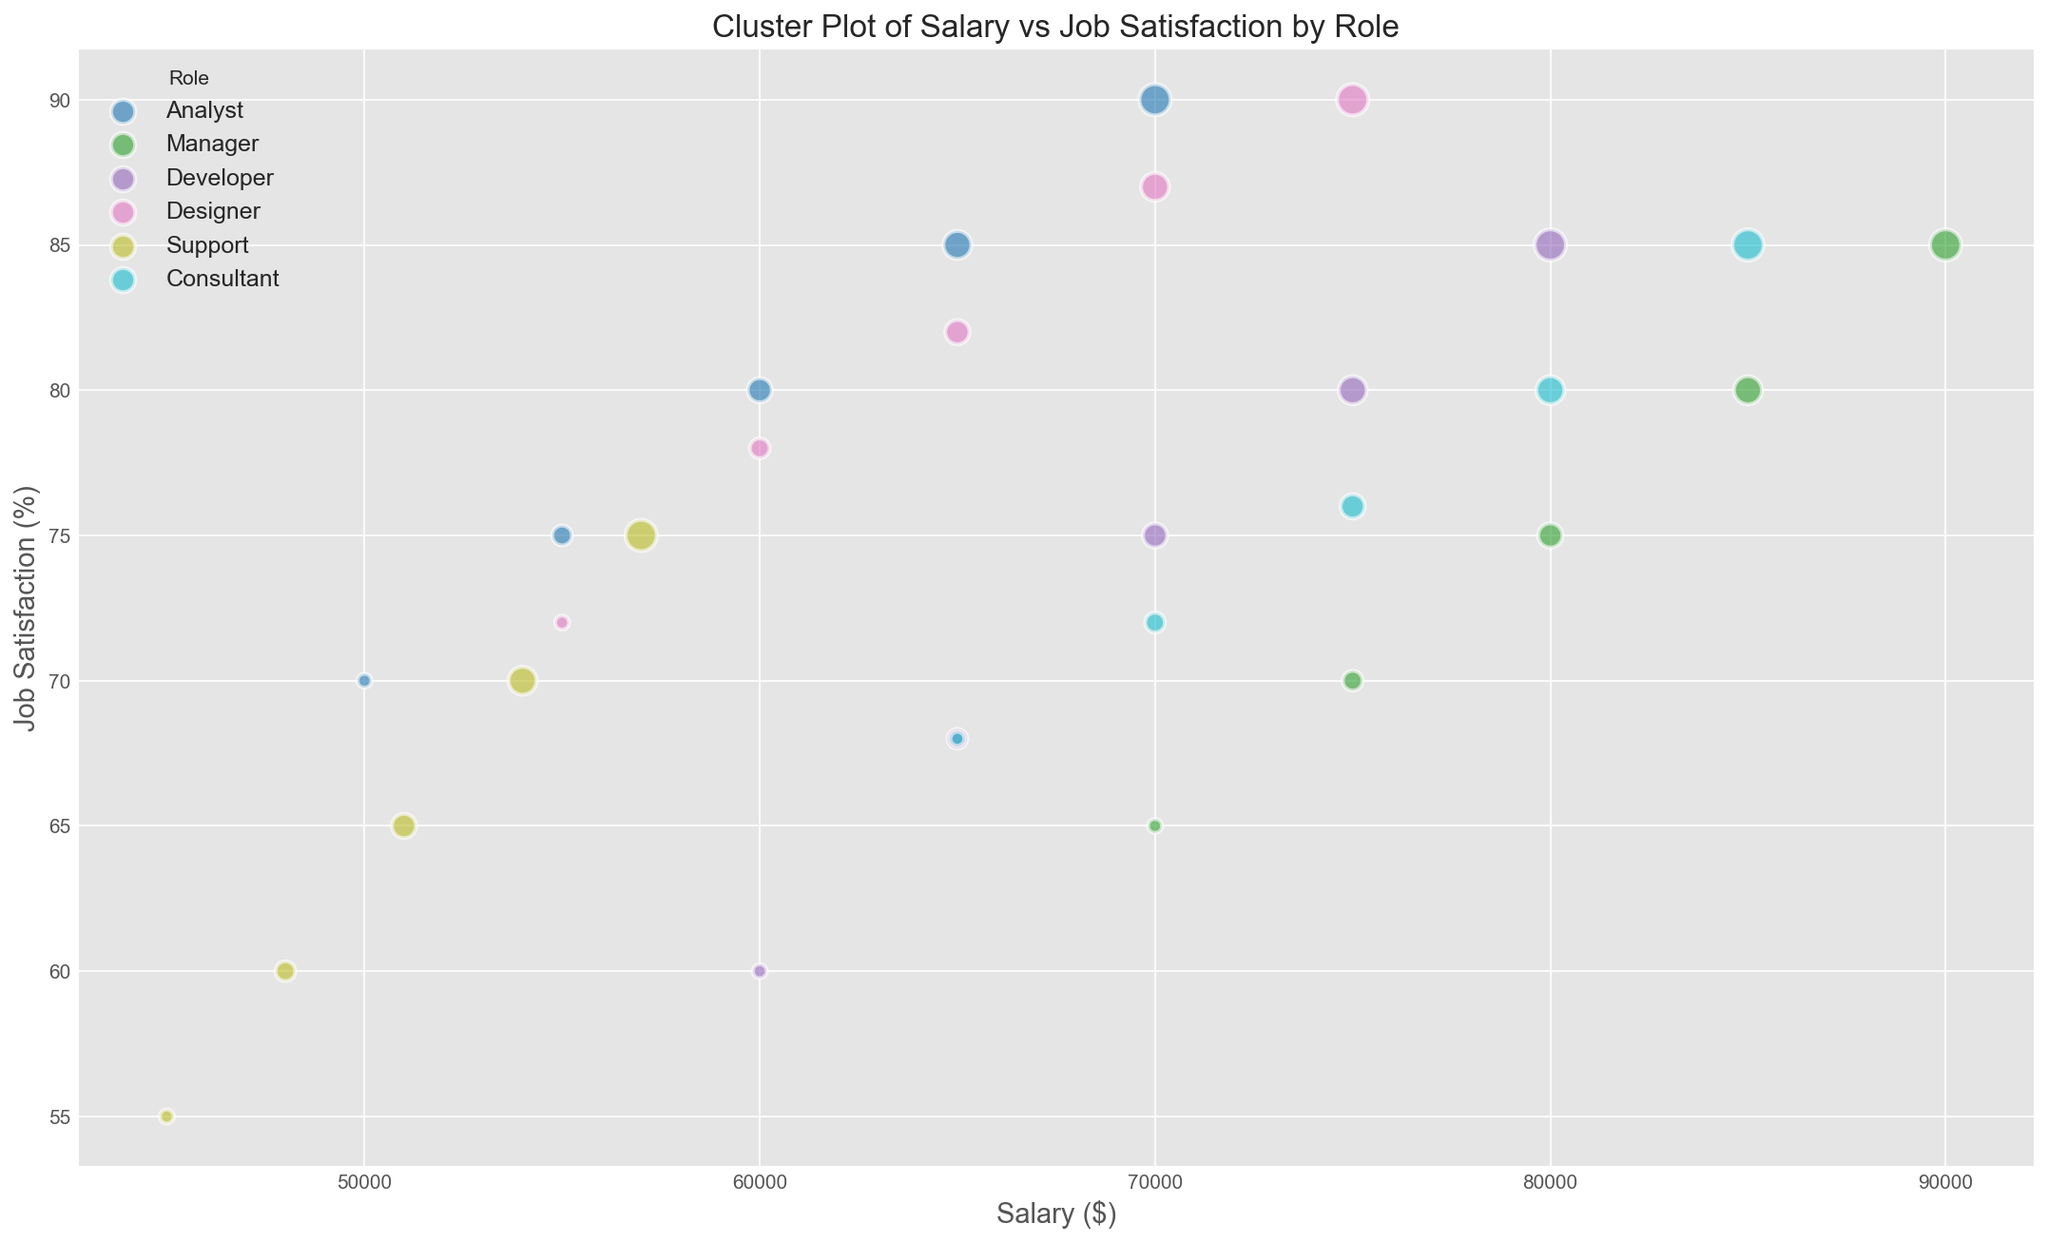What is the highest job satisfaction percentage for the Developer role? From the scatter plot, identify the Developer role (which should have a unique color). Look for the point within this category that has the highest y-axis value, which represents job satisfaction.
Answer: 85% Which role has the highest average salary, and what is that average? Identify the distinct colors for each role. Calculate the average salary for each role by summing the salaries of all data points of that role and dividing by the number of data points. Compare these averages to find the highest one.
Answer: Manager, $80,000 Which role with a tenure of 3 years has the least job satisfaction? Look at the size of the scatter points (larger ones for higher tenure). Focus on the medium-sized points and check their job satisfaction values on the y-axis. Compare the points for tenure 3 years across all roles to find the smallest y-value.
Answer: Support, 65% Are there any roles where the job satisfaction remains constant regardless of tenure? Identify the points for each role based on color. For each role, check if the y-values (job satisfaction) change with the x-values (tenure). If the y-values remain constant across different tenures, that role has constant job satisfaction.
Answer: No role shows constant job satisfaction Is there a role that generally has higher job satisfaction compared to others? Compare the spread and height of the points (y-axis position) for each role. Look at which role has consistently higher values on the y-axis across the range of salaries and tenures.
Answer: Analyst For Manager roles, what is the difference in salary between the person with the highest and lowest job satisfaction? Focus on the points for Manager roles. Identify the points with the highest and lowest job satisfaction (y-axis values). Note their corresponding salaries (x-axis values) and calculate the difference.
Answer: $20,000 (90,000 - 70,000) How does job satisfaction vary for Support roles as tenure increases? Focus on the points representing Support roles and note their different sizes (tenure). Observe the trend in y-axis values (job satisfaction) as the size of points increases, indicating increasing tenure.
Answer: Job satisfaction increases with tenure What is the median salary for the Designer role? Identify the points for the Designer role. List the salaries in ascending order and find the middle value.
Answer: $65000 Which role shows the highest job satisfaction for a starting tenure of 1 year? Identify the smallest points across all roles (indicating 1 year of tenure). Compare their y-axis values to find the highest one.
Answer: Designer 